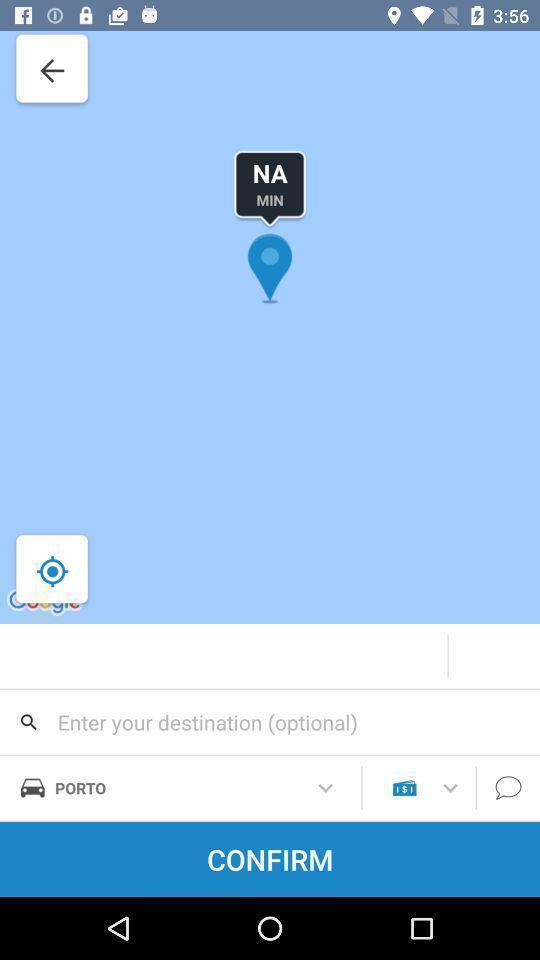Give me a summary of this screen capture. Screen displaying search bar to book a ride. 